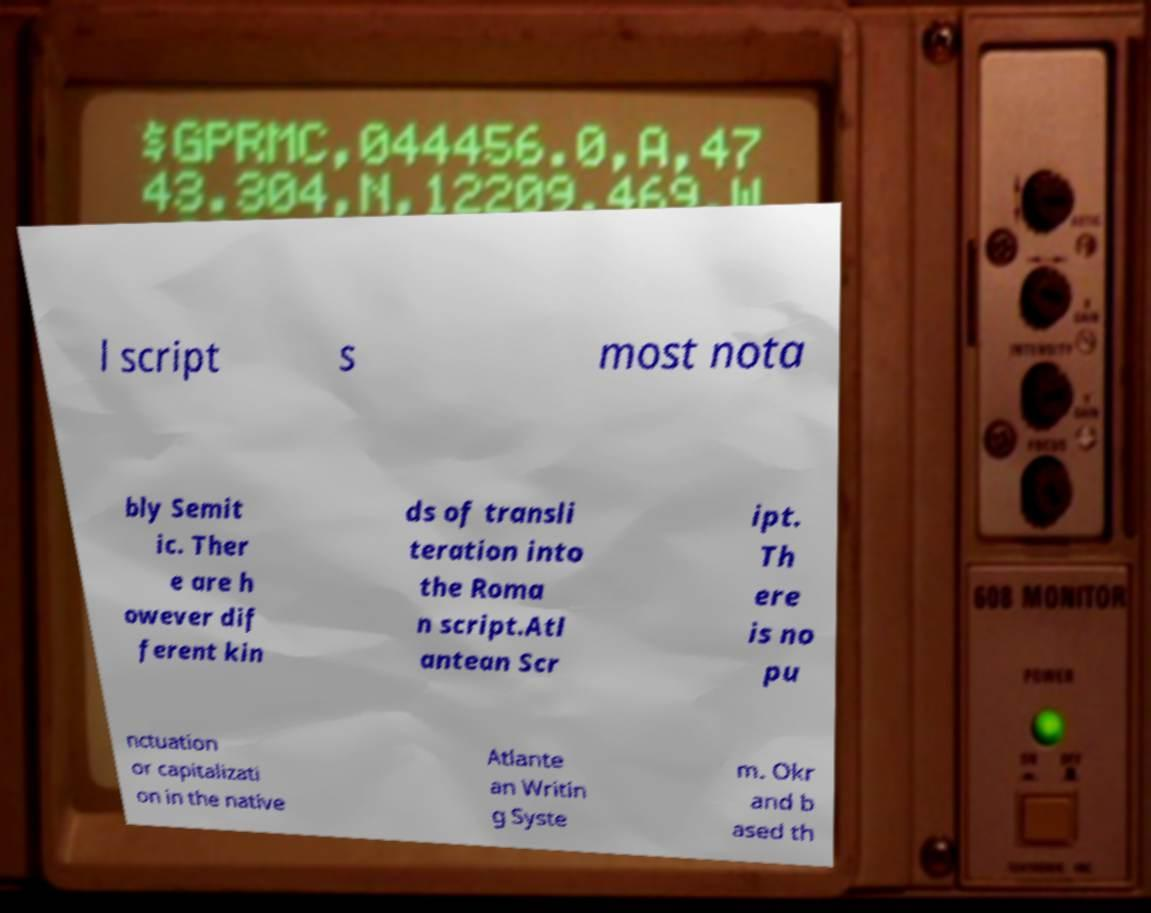Can you accurately transcribe the text from the provided image for me? l script s most nota bly Semit ic. Ther e are h owever dif ferent kin ds of transli teration into the Roma n script.Atl antean Scr ipt. Th ere is no pu nctuation or capitalizati on in the native Atlante an Writin g Syste m. Okr and b ased th 